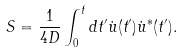<formula> <loc_0><loc_0><loc_500><loc_500>S = \frac { 1 } { 4 D } \int _ { 0 } ^ { t } d t ^ { \prime } \dot { u } ( t ^ { \prime } ) \dot { u } ^ { * } ( t ^ { \prime } ) .</formula> 